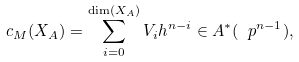<formula> <loc_0><loc_0><loc_500><loc_500>c _ { M } ( X _ { A } ) = \sum _ { i = 0 } ^ { \dim ( X _ { A } ) } V _ { i } h ^ { n - i } \in A ^ { * } ( \ p ^ { n - 1 } ) ,</formula> 